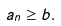Convert formula to latex. <formula><loc_0><loc_0><loc_500><loc_500>a _ { n } \geq b .</formula> 